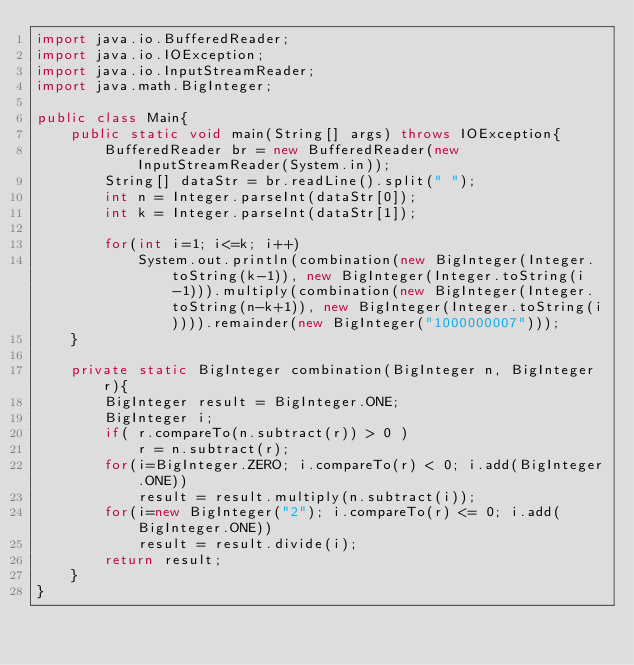Convert code to text. <code><loc_0><loc_0><loc_500><loc_500><_Java_>import java.io.BufferedReader;
import java.io.IOException;
import java.io.InputStreamReader;
import java.math.BigInteger;

public class Main{
	public static void main(String[] args) throws IOException{
		BufferedReader br = new BufferedReader(new InputStreamReader(System.in));
		String[] dataStr = br.readLine().split(" ");
		int n = Integer.parseInt(dataStr[0]);
		int k = Integer.parseInt(dataStr[1]);
		
		for(int i=1; i<=k; i++)
			System.out.println(combination(new BigInteger(Integer.toString(k-1)), new BigInteger(Integer.toString(i-1))).multiply(combination(new BigInteger(Integer.toString(n-k+1)), new BigInteger(Integer.toString(i)))).remainder(new BigInteger("1000000007")));
	}
	
	private static BigInteger combination(BigInteger n, BigInteger r){
		BigInteger result = BigInteger.ONE;
		BigInteger i;
		if( r.compareTo(n.subtract(r)) > 0 )
			r = n.subtract(r);
		for(i=BigInteger.ZERO; i.compareTo(r) < 0; i.add(BigInteger.ONE))
			result = result.multiply(n.subtract(i));
		for(i=new BigInteger("2"); i.compareTo(r) <= 0; i.add(BigInteger.ONE))
			result = result.divide(i);
		return result;
	}
}
</code> 